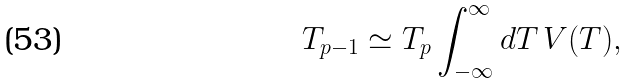Convert formula to latex. <formula><loc_0><loc_0><loc_500><loc_500>T _ { p - 1 } \simeq T _ { p } \int ^ { \infty } _ { - \infty } d T \, V ( T ) ,</formula> 